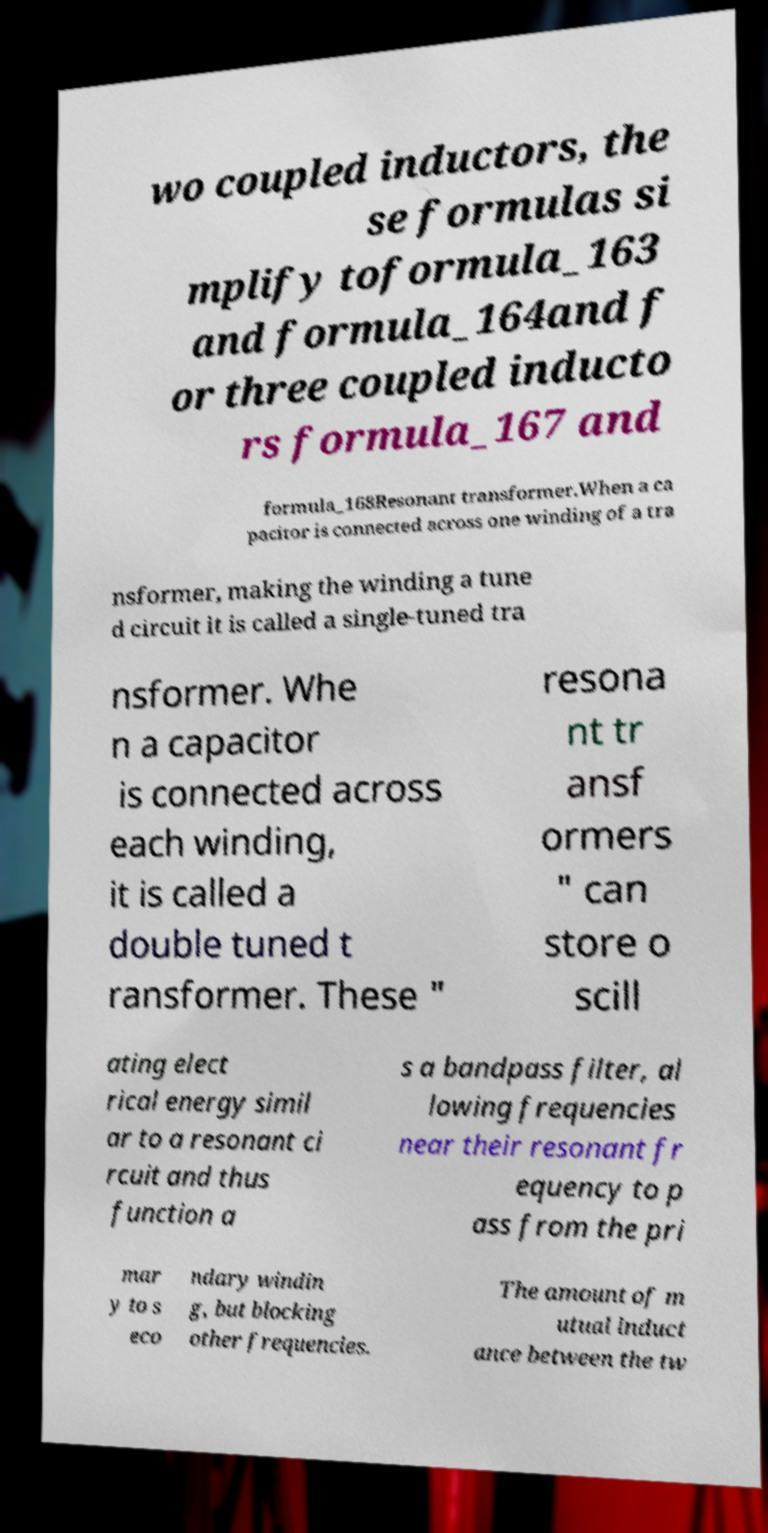Please read and relay the text visible in this image. What does it say? wo coupled inductors, the se formulas si mplify toformula_163 and formula_164and f or three coupled inducto rs formula_167 and formula_168Resonant transformer.When a ca pacitor is connected across one winding of a tra nsformer, making the winding a tune d circuit it is called a single-tuned tra nsformer. Whe n a capacitor is connected across each winding, it is called a double tuned t ransformer. These " resona nt tr ansf ormers " can store o scill ating elect rical energy simil ar to a resonant ci rcuit and thus function a s a bandpass filter, al lowing frequencies near their resonant fr equency to p ass from the pri mar y to s eco ndary windin g, but blocking other frequencies. The amount of m utual induct ance between the tw 